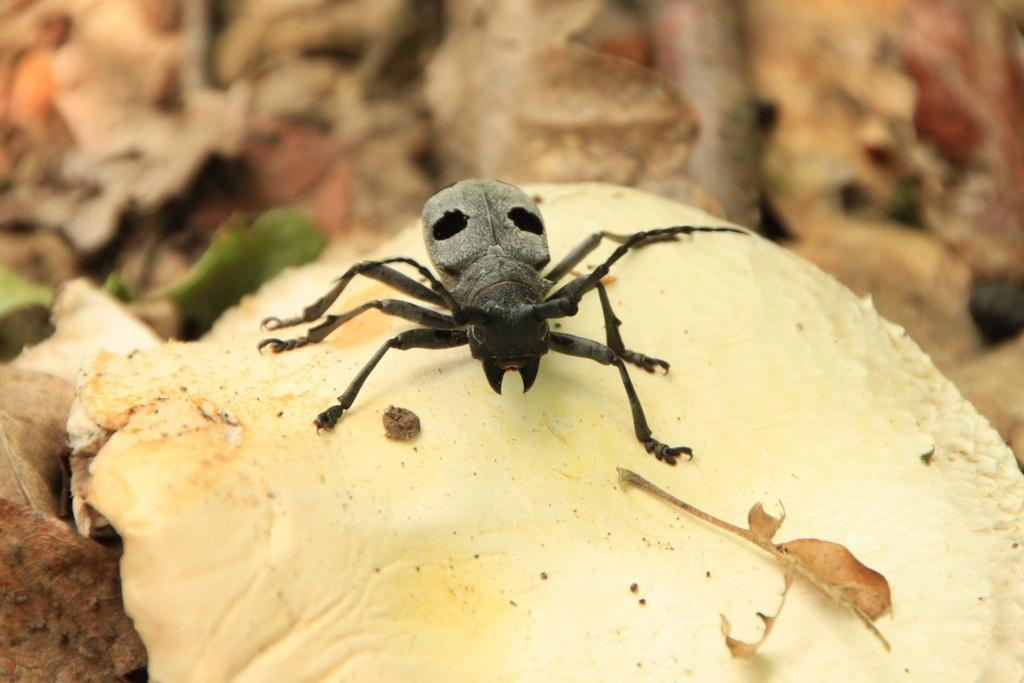What is present on the mushroom in the image? There is an insect on a mushroom in the image. Where is the mushroom located in the image? The mushroom is on the left side of the image. What color is the background of the image? The background of the image is brown. How many islands can be seen in the image? There are no islands present in the image. What type of act is the insect performing on the mushroom? The image does not depict any specific act being performed by the insect on the mushroom. 